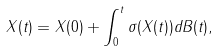Convert formula to latex. <formula><loc_0><loc_0><loc_500><loc_500>X ( t ) = X ( 0 ) + \int _ { 0 } ^ { t } \sigma ( X ( t ) ) d B ( t ) ,</formula> 